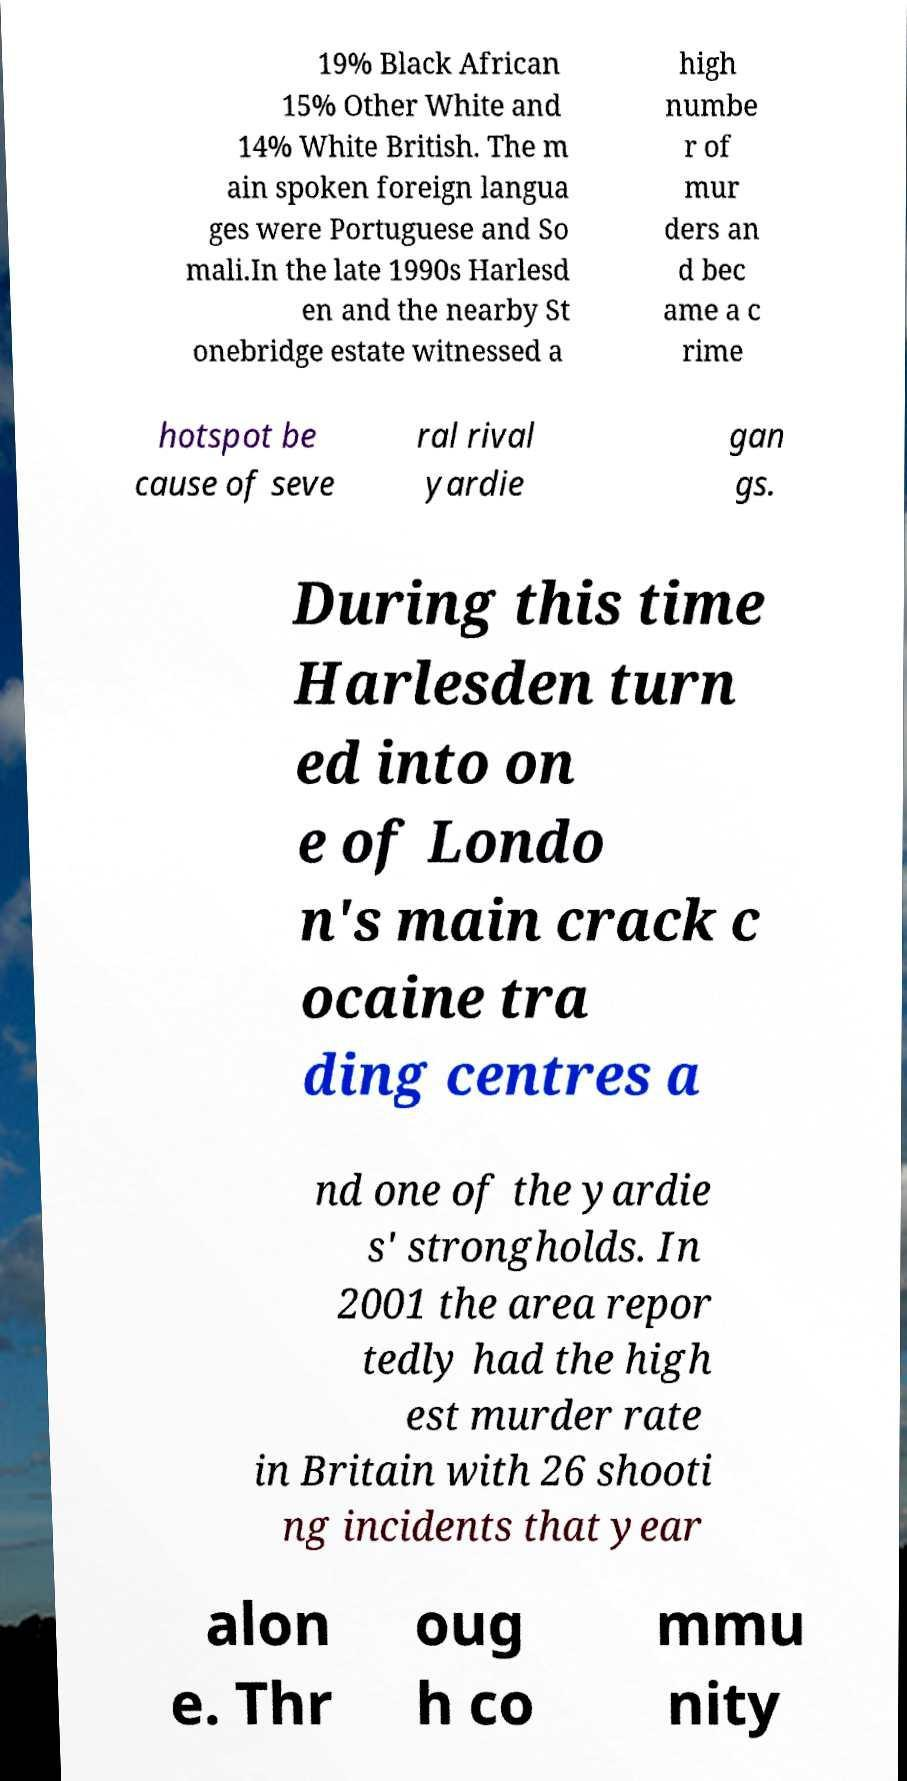What messages or text are displayed in this image? I need them in a readable, typed format. 19% Black African 15% Other White and 14% White British. The m ain spoken foreign langua ges were Portuguese and So mali.In the late 1990s Harlesd en and the nearby St onebridge estate witnessed a high numbe r of mur ders an d bec ame a c rime hotspot be cause of seve ral rival yardie gan gs. During this time Harlesden turn ed into on e of Londo n's main crack c ocaine tra ding centres a nd one of the yardie s' strongholds. In 2001 the area repor tedly had the high est murder rate in Britain with 26 shooti ng incidents that year alon e. Thr oug h co mmu nity 